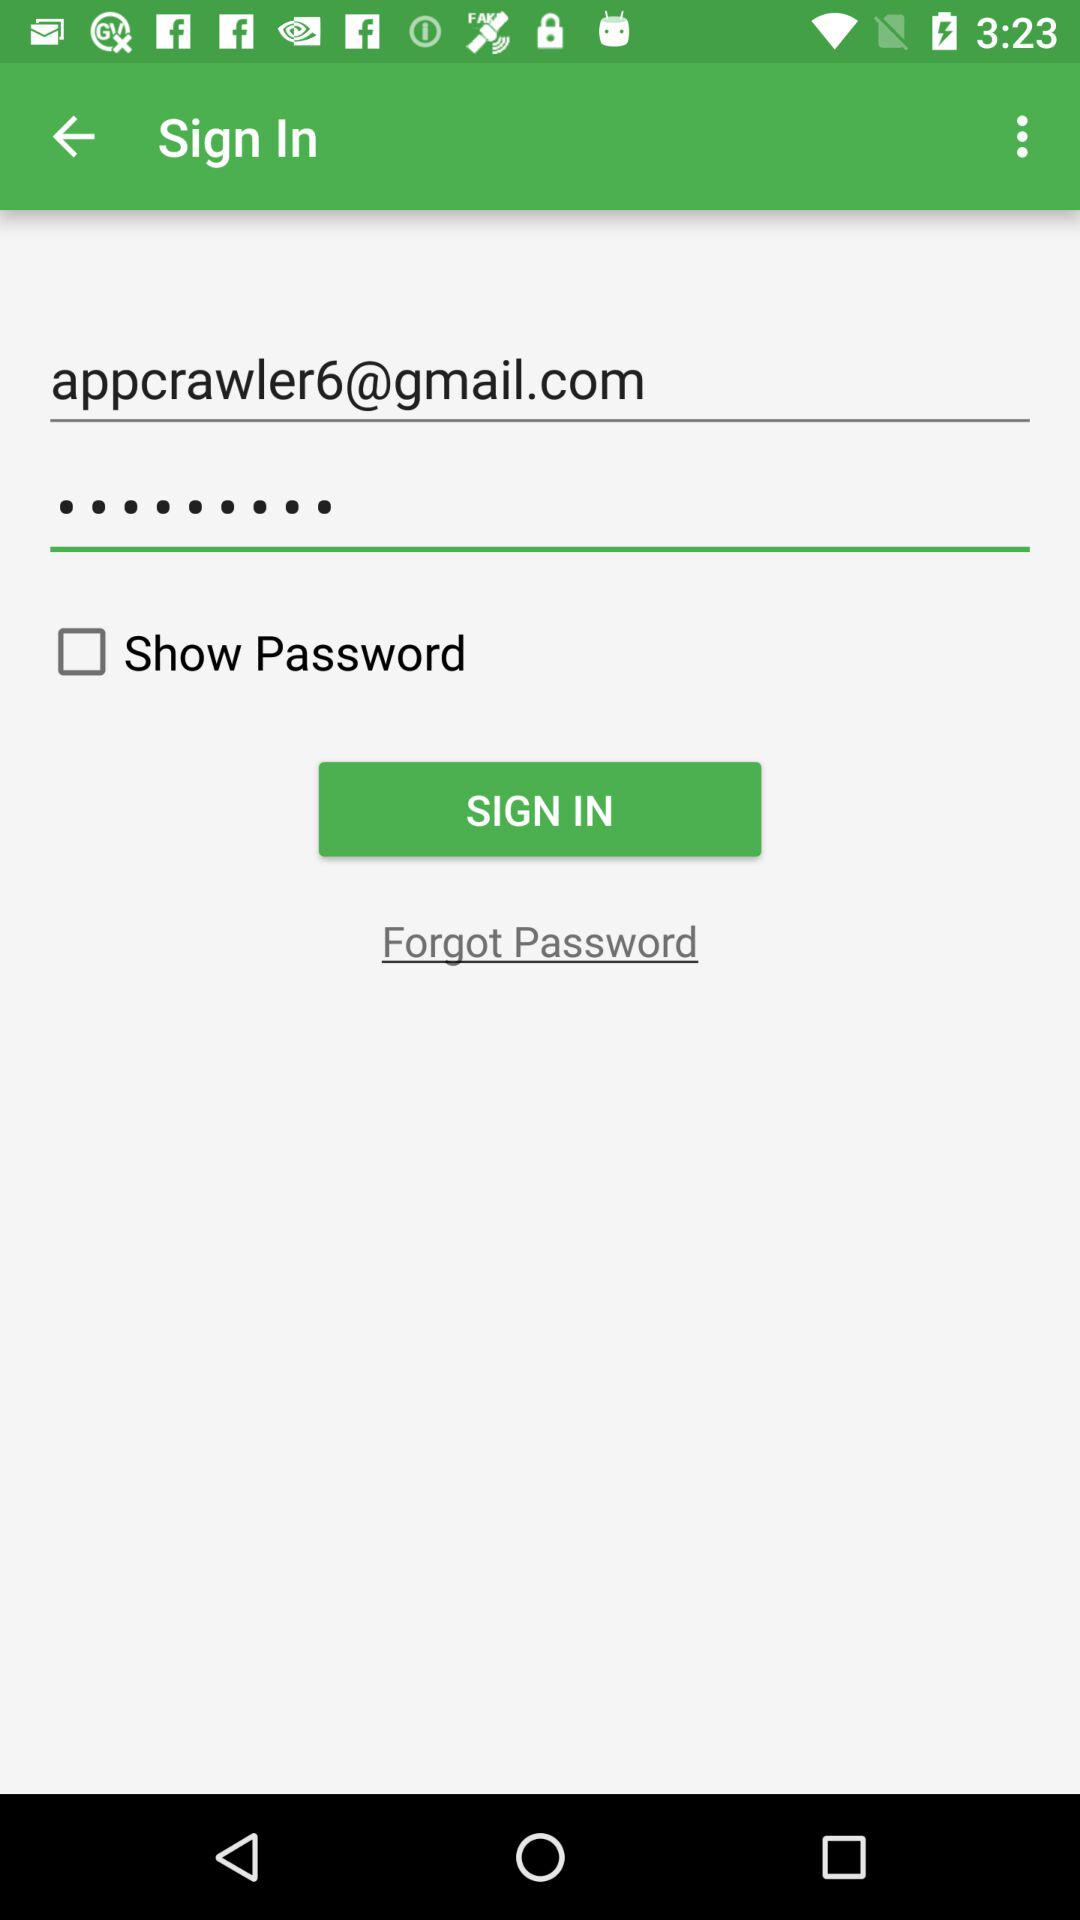How many textboxes are there in the sign in form?
Answer the question using a single word or phrase. 2 